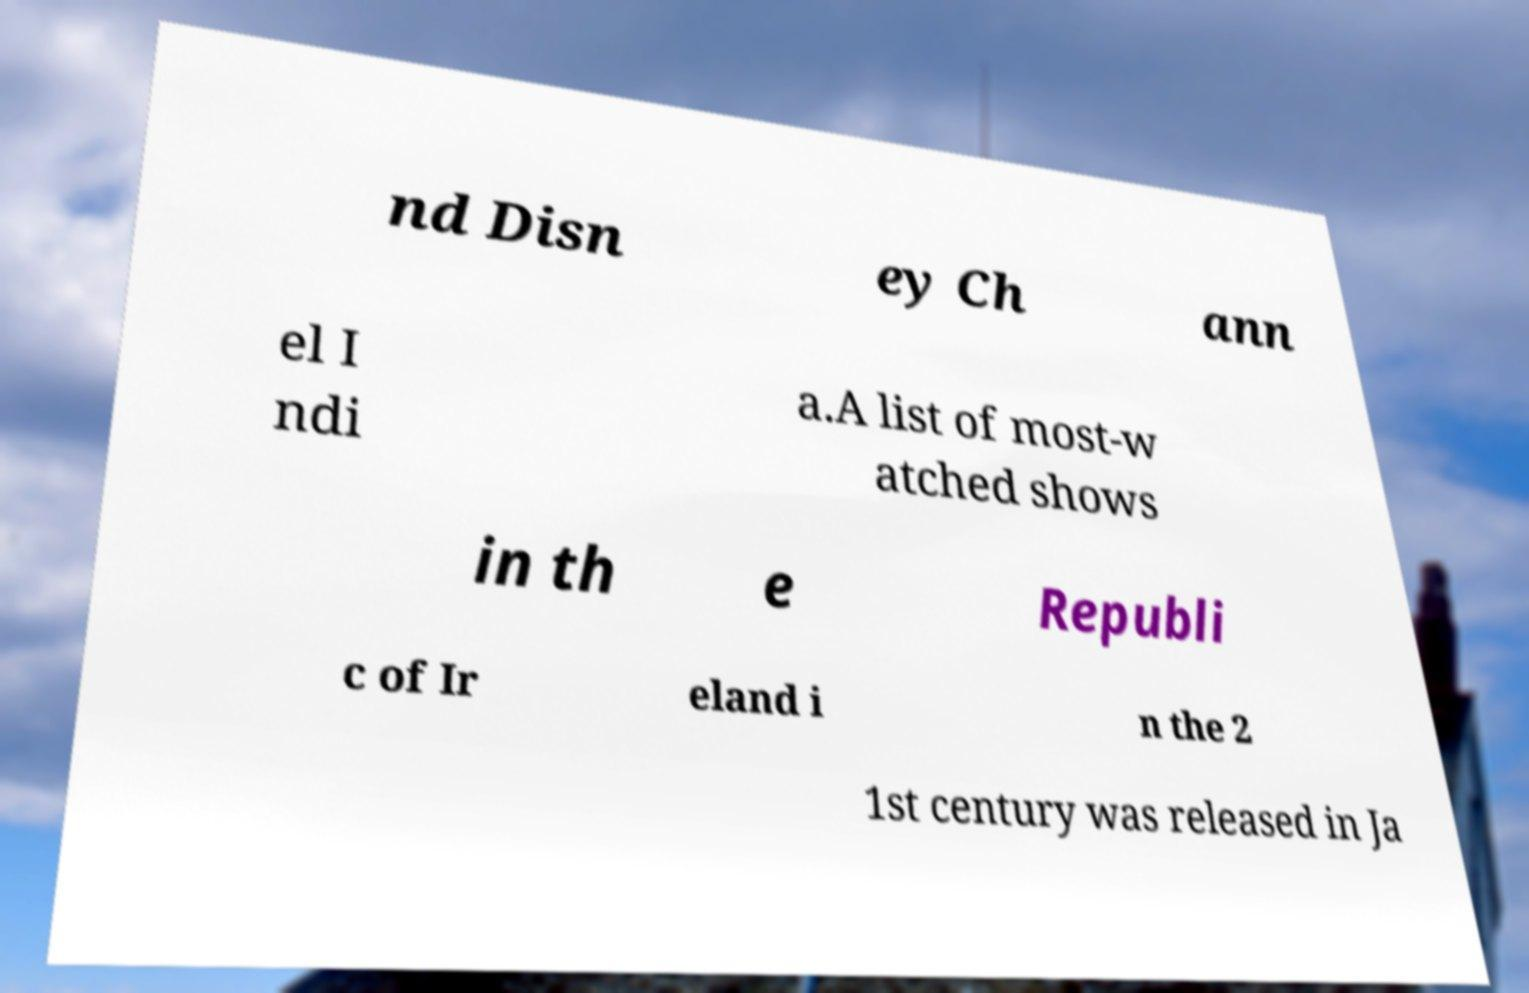Can you accurately transcribe the text from the provided image for me? nd Disn ey Ch ann el I ndi a.A list of most-w atched shows in th e Republi c of Ir eland i n the 2 1st century was released in Ja 